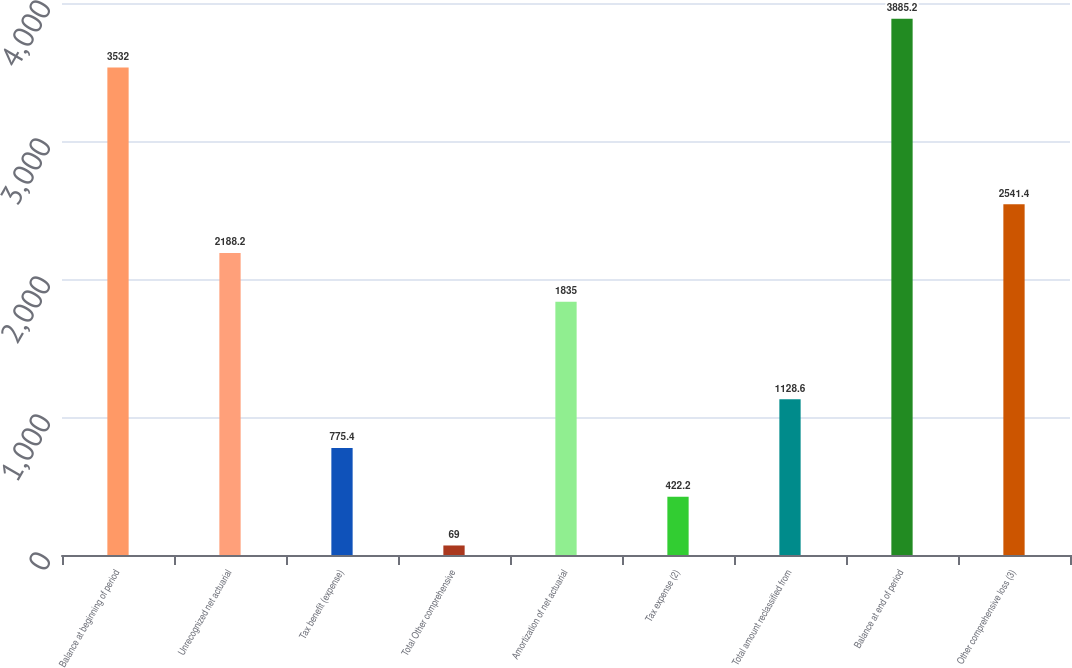<chart> <loc_0><loc_0><loc_500><loc_500><bar_chart><fcel>Balance at beginning of period<fcel>Unrecognized net actuarial<fcel>Tax benefit (expense)<fcel>Total Other comprehensive<fcel>Amortization of net actuarial<fcel>Tax expense (2)<fcel>Total amount reclassified from<fcel>Balance at end of period<fcel>Other comprehensive loss (3)<nl><fcel>3532<fcel>2188.2<fcel>775.4<fcel>69<fcel>1835<fcel>422.2<fcel>1128.6<fcel>3885.2<fcel>2541.4<nl></chart> 